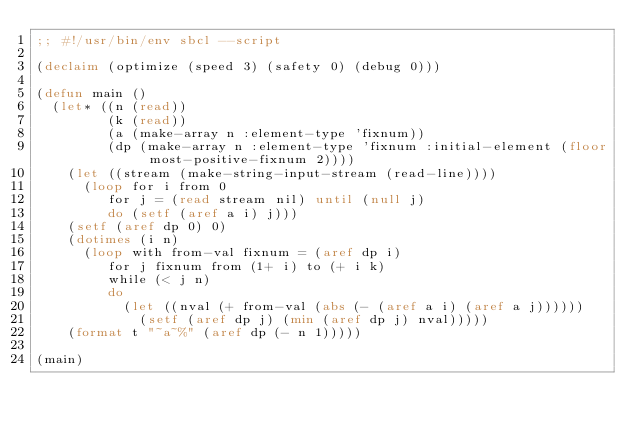<code> <loc_0><loc_0><loc_500><loc_500><_Lisp_>;; #!/usr/bin/env sbcl --script

(declaim (optimize (speed 3) (safety 0) (debug 0)))

(defun main ()
  (let* ((n (read))
         (k (read))
         (a (make-array n :element-type 'fixnum))
         (dp (make-array n :element-type 'fixnum :initial-element (floor most-positive-fixnum 2))))
    (let ((stream (make-string-input-stream (read-line))))
      (loop for i from 0
         for j = (read stream nil) until (null j)
         do (setf (aref a i) j)))
    (setf (aref dp 0) 0)
    (dotimes (i n)
      (loop with from-val fixnum = (aref dp i)
         for j fixnum from (1+ i) to (+ i k)
         while (< j n)
         do
           (let ((nval (+ from-val (abs (- (aref a i) (aref a j))))))
             (setf (aref dp j) (min (aref dp j) nval)))))
    (format t "~a~%" (aref dp (- n 1)))))

(main)
</code> 